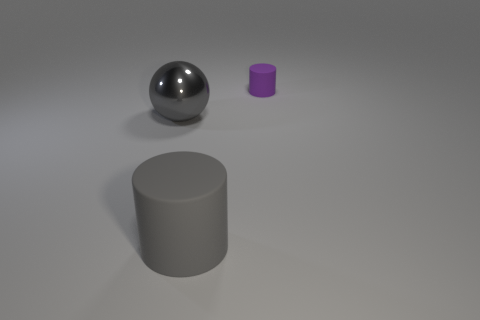Add 2 cylinders. How many objects exist? 5 Subtract all cylinders. How many objects are left? 1 Add 1 purple matte things. How many purple matte things are left? 2 Add 1 big metal balls. How many big metal balls exist? 2 Subtract 0 yellow spheres. How many objects are left? 3 Subtract all rubber objects. Subtract all purple metal cylinders. How many objects are left? 1 